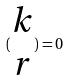Convert formula to latex. <formula><loc_0><loc_0><loc_500><loc_500>( \begin{matrix} k \\ r \end{matrix} ) = 0</formula> 